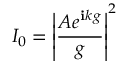Convert formula to latex. <formula><loc_0><loc_0><loc_500><loc_500>I _ { 0 } = \left | { \frac { A e ^ { i k g } } { g } } \right | ^ { 2 }</formula> 